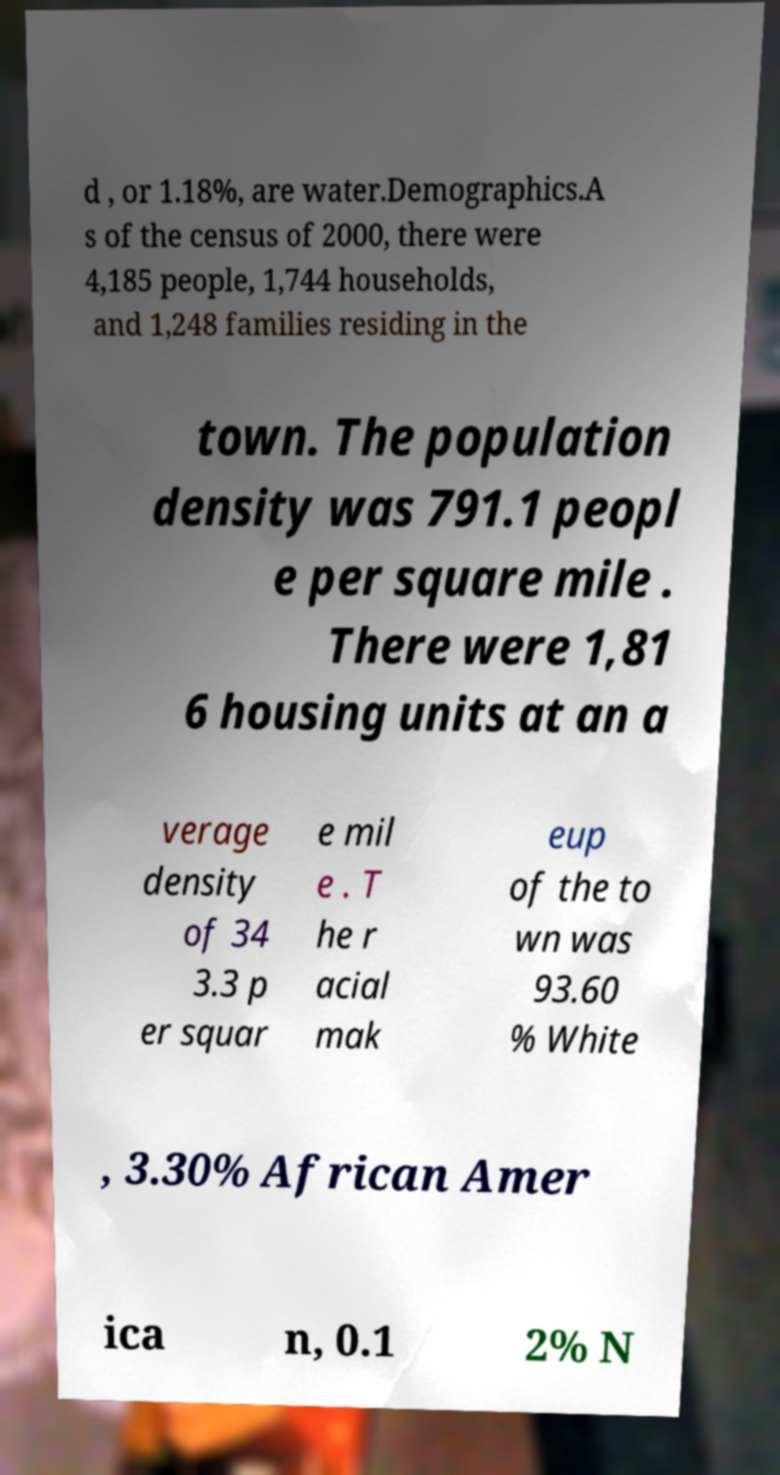Please read and relay the text visible in this image. What does it say? d , or 1.18%, are water.Demographics.A s of the census of 2000, there were 4,185 people, 1,744 households, and 1,248 families residing in the town. The population density was 791.1 peopl e per square mile . There were 1,81 6 housing units at an a verage density of 34 3.3 p er squar e mil e . T he r acial mak eup of the to wn was 93.60 % White , 3.30% African Amer ica n, 0.1 2% N 